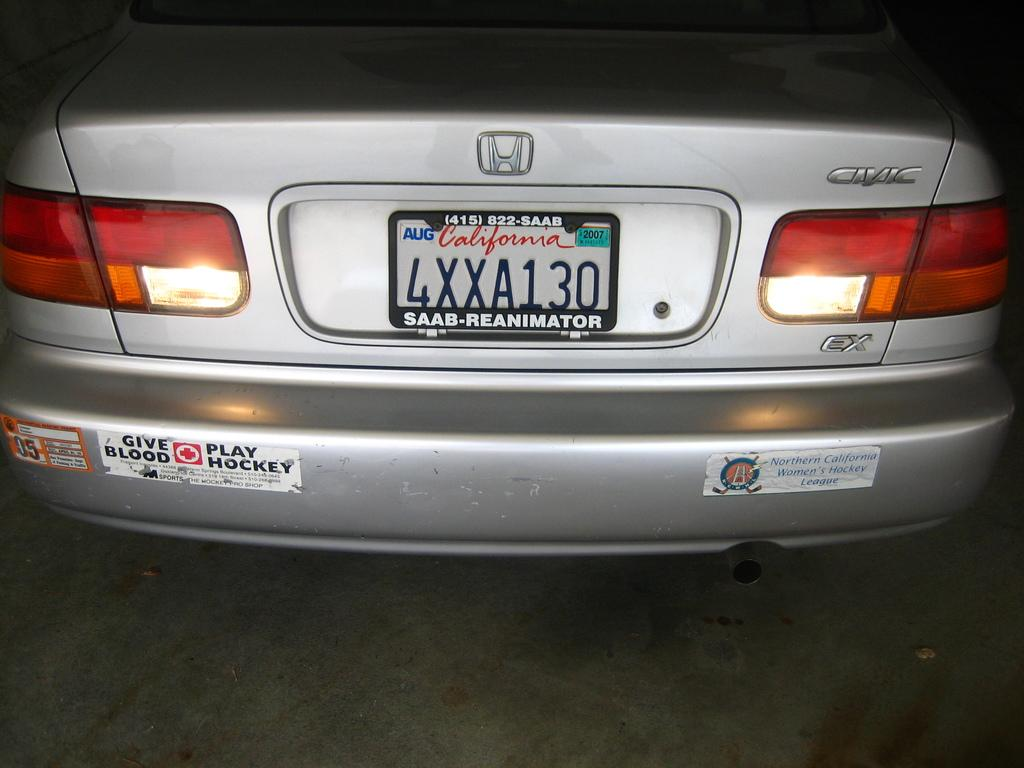Provide a one-sentence caption for the provided image. The rear end of a silver Honda Civic has a give blood play hockey bumper sticker. 